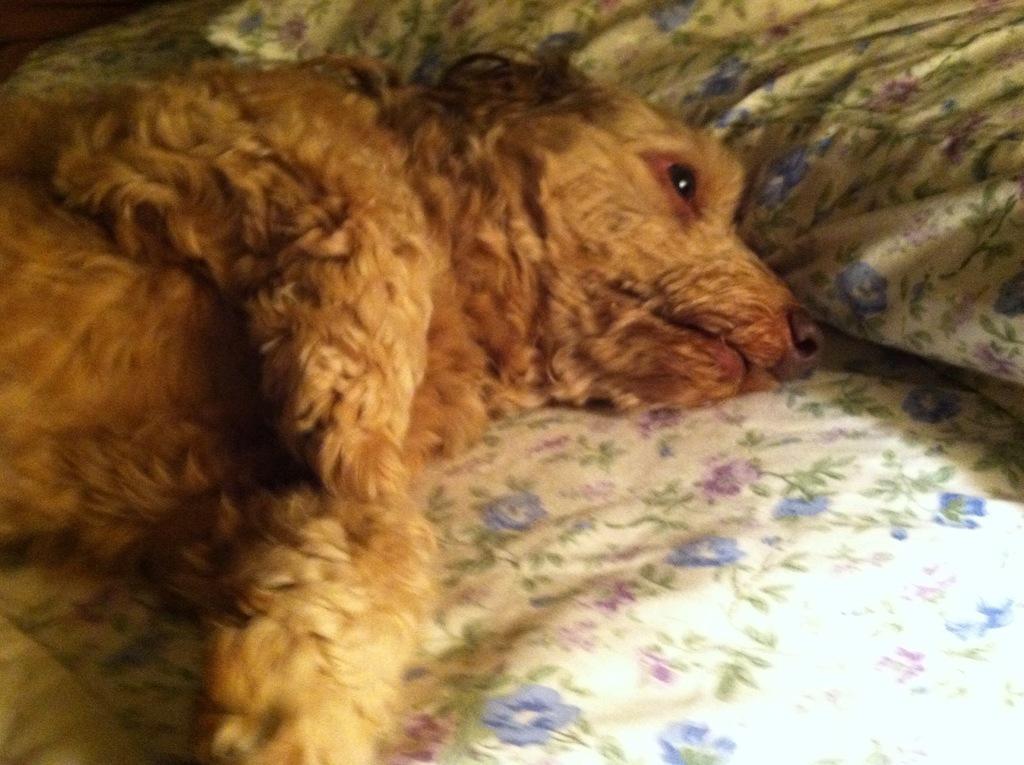How would you summarize this image in a sentence or two? In this image in the center there is one animal and at the bottom there is bed, on the bed there is one blanket and pillow. 